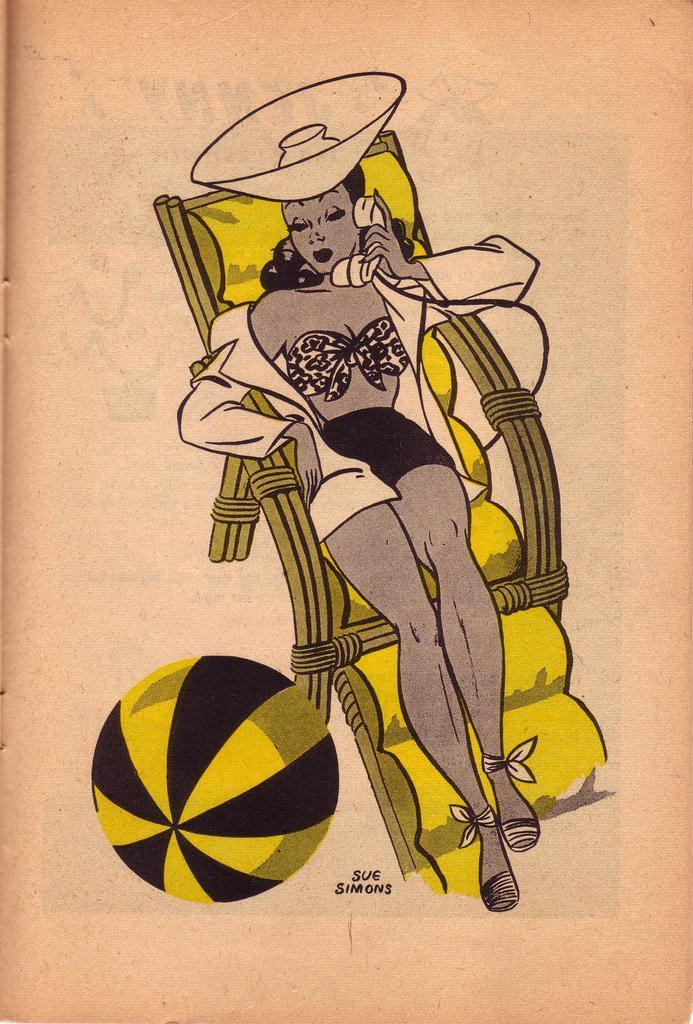Who is present in the image? There is a woman in the image. What is the woman doing in the image? The woman is sitting on a chair. What is the woman holding in the image? The woman is holding a phone. What is the woman wearing on her head in the image? The woman is wearing a cap. Can you describe the surroundings of the woman in the image? There might be a wall beside the chair. What type of straw is the woman using to sit on the throne in the image? There is no throne present in the image, and the woman is sitting on a chair, not a throne. Additionally, there is no straw mentioned or visible in the image. 